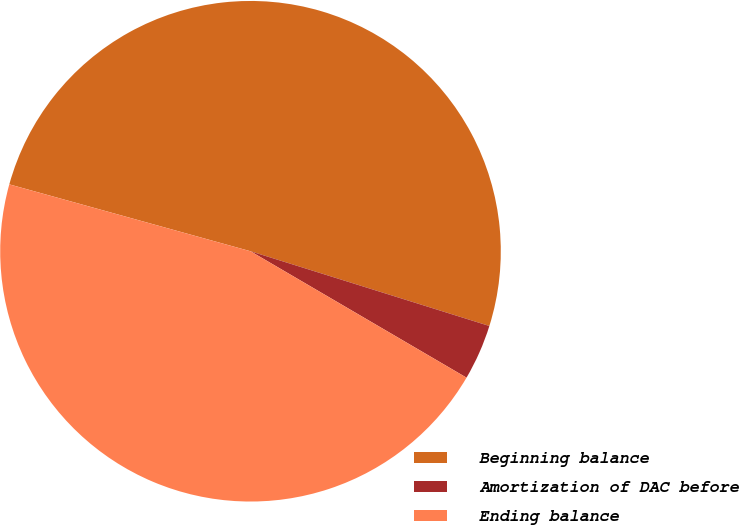Convert chart to OTSL. <chart><loc_0><loc_0><loc_500><loc_500><pie_chart><fcel>Beginning balance<fcel>Amortization of DAC before<fcel>Ending balance<nl><fcel>50.52%<fcel>3.6%<fcel>45.88%<nl></chart> 